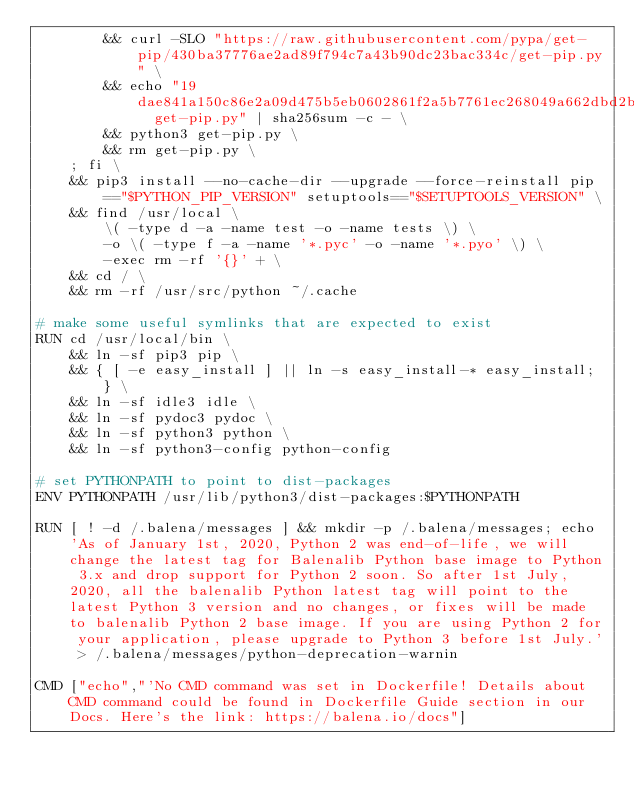Convert code to text. <code><loc_0><loc_0><loc_500><loc_500><_Dockerfile_>		&& curl -SLO "https://raw.githubusercontent.com/pypa/get-pip/430ba37776ae2ad89f794c7a43b90dc23bac334c/get-pip.py" \
		&& echo "19dae841a150c86e2a09d475b5eb0602861f2a5b7761ec268049a662dbd2bd0c  get-pip.py" | sha256sum -c - \
		&& python3 get-pip.py \
		&& rm get-pip.py \
	; fi \
	&& pip3 install --no-cache-dir --upgrade --force-reinstall pip=="$PYTHON_PIP_VERSION" setuptools=="$SETUPTOOLS_VERSION" \
	&& find /usr/local \
		\( -type d -a -name test -o -name tests \) \
		-o \( -type f -a -name '*.pyc' -o -name '*.pyo' \) \
		-exec rm -rf '{}' + \
	&& cd / \
	&& rm -rf /usr/src/python ~/.cache

# make some useful symlinks that are expected to exist
RUN cd /usr/local/bin \
	&& ln -sf pip3 pip \
	&& { [ -e easy_install ] || ln -s easy_install-* easy_install; } \
	&& ln -sf idle3 idle \
	&& ln -sf pydoc3 pydoc \
	&& ln -sf python3 python \
	&& ln -sf python3-config python-config

# set PYTHONPATH to point to dist-packages
ENV PYTHONPATH /usr/lib/python3/dist-packages:$PYTHONPATH

RUN [ ! -d /.balena/messages ] && mkdir -p /.balena/messages; echo 'As of January 1st, 2020, Python 2 was end-of-life, we will change the latest tag for Balenalib Python base image to Python 3.x and drop support for Python 2 soon. So after 1st July, 2020, all the balenalib Python latest tag will point to the latest Python 3 version and no changes, or fixes will be made to balenalib Python 2 base image. If you are using Python 2 for your application, please upgrade to Python 3 before 1st July.' > /.balena/messages/python-deprecation-warnin

CMD ["echo","'No CMD command was set in Dockerfile! Details about CMD command could be found in Dockerfile Guide section in our Docs. Here's the link: https://balena.io/docs"]
</code> 